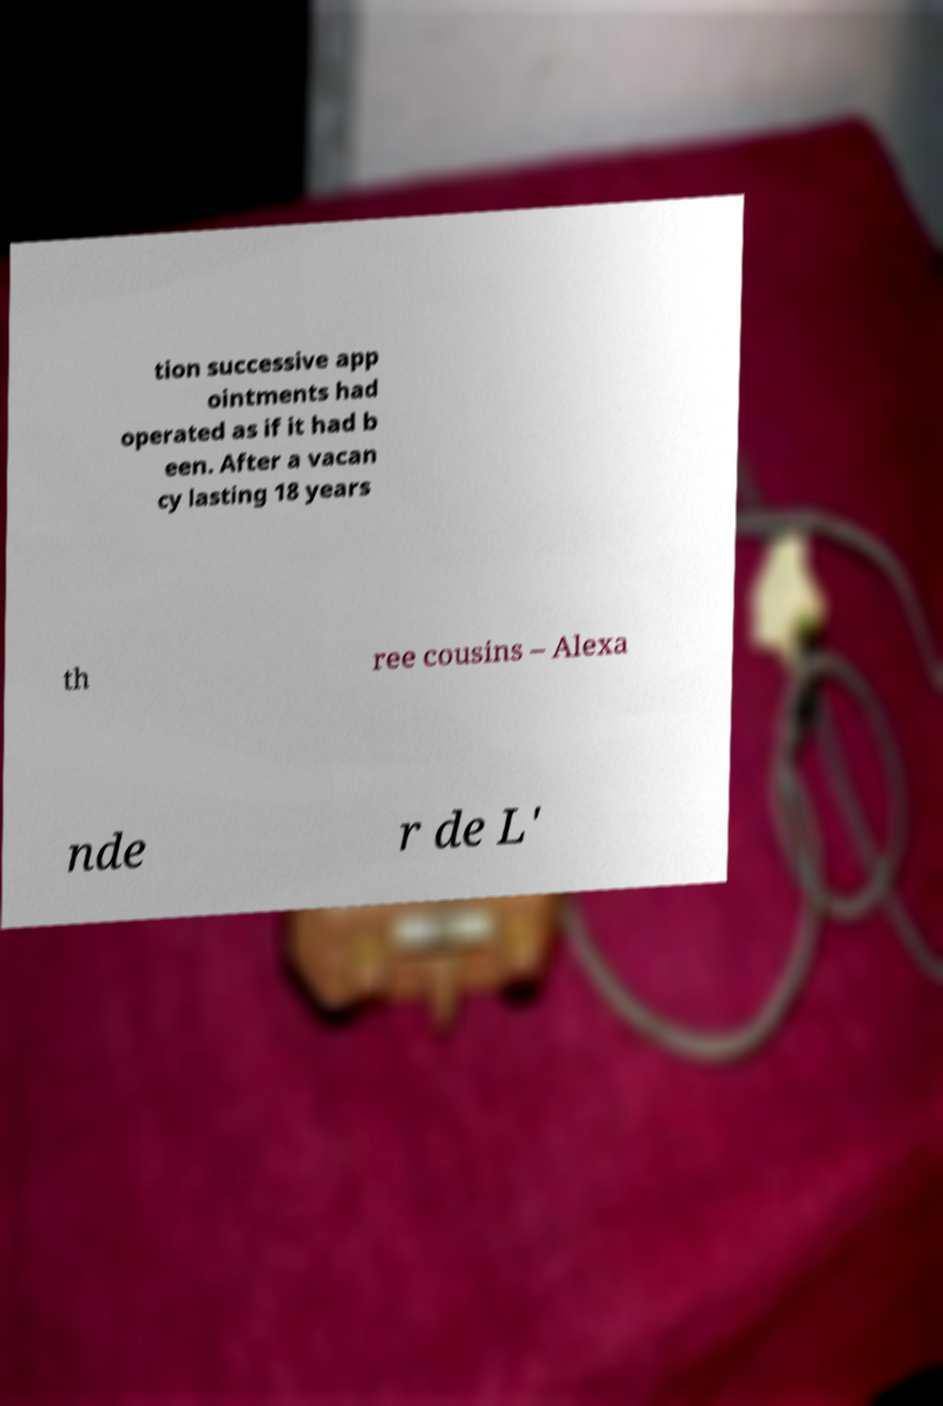Please read and relay the text visible in this image. What does it say? tion successive app ointments had operated as if it had b een. After a vacan cy lasting 18 years th ree cousins – Alexa nde r de L' 